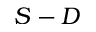<formula> <loc_0><loc_0><loc_500><loc_500>S - D</formula> 